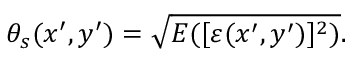Convert formula to latex. <formula><loc_0><loc_0><loc_500><loc_500>\theta _ { s } ( x ^ { \prime } , y ^ { \prime } ) = \sqrt { E ( [ \varepsilon ( x ^ { \prime } , y ^ { \prime } ) ] ^ { 2 } ) } .</formula> 